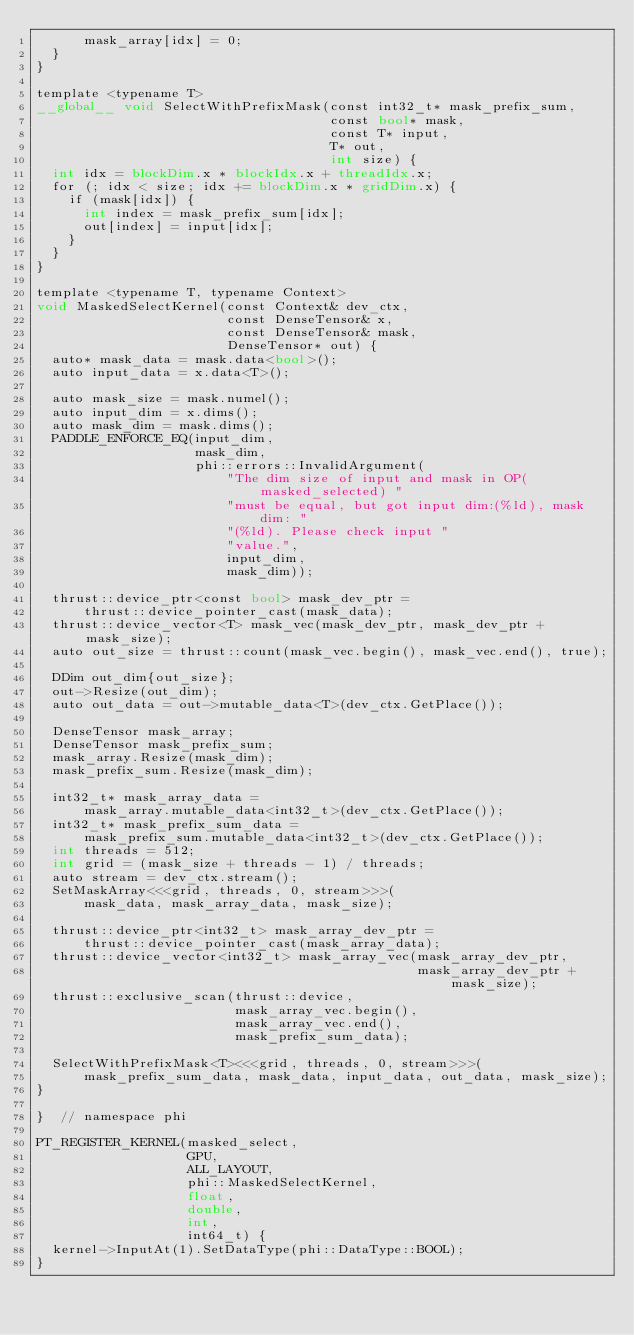Convert code to text. <code><loc_0><loc_0><loc_500><loc_500><_Cuda_>      mask_array[idx] = 0;
  }
}

template <typename T>
__global__ void SelectWithPrefixMask(const int32_t* mask_prefix_sum,
                                     const bool* mask,
                                     const T* input,
                                     T* out,
                                     int size) {
  int idx = blockDim.x * blockIdx.x + threadIdx.x;
  for (; idx < size; idx += blockDim.x * gridDim.x) {
    if (mask[idx]) {
      int index = mask_prefix_sum[idx];
      out[index] = input[idx];
    }
  }
}

template <typename T, typename Context>
void MaskedSelectKernel(const Context& dev_ctx,
                        const DenseTensor& x,
                        const DenseTensor& mask,
                        DenseTensor* out) {
  auto* mask_data = mask.data<bool>();
  auto input_data = x.data<T>();

  auto mask_size = mask.numel();
  auto input_dim = x.dims();
  auto mask_dim = mask.dims();
  PADDLE_ENFORCE_EQ(input_dim,
                    mask_dim,
                    phi::errors::InvalidArgument(
                        "The dim size of input and mask in OP(masked_selected) "
                        "must be equal, but got input dim:(%ld), mask dim: "
                        "(%ld). Please check input "
                        "value.",
                        input_dim,
                        mask_dim));

  thrust::device_ptr<const bool> mask_dev_ptr =
      thrust::device_pointer_cast(mask_data);
  thrust::device_vector<T> mask_vec(mask_dev_ptr, mask_dev_ptr + mask_size);
  auto out_size = thrust::count(mask_vec.begin(), mask_vec.end(), true);

  DDim out_dim{out_size};
  out->Resize(out_dim);
  auto out_data = out->mutable_data<T>(dev_ctx.GetPlace());

  DenseTensor mask_array;
  DenseTensor mask_prefix_sum;
  mask_array.Resize(mask_dim);
  mask_prefix_sum.Resize(mask_dim);

  int32_t* mask_array_data =
      mask_array.mutable_data<int32_t>(dev_ctx.GetPlace());
  int32_t* mask_prefix_sum_data =
      mask_prefix_sum.mutable_data<int32_t>(dev_ctx.GetPlace());
  int threads = 512;
  int grid = (mask_size + threads - 1) / threads;
  auto stream = dev_ctx.stream();
  SetMaskArray<<<grid, threads, 0, stream>>>(
      mask_data, mask_array_data, mask_size);

  thrust::device_ptr<int32_t> mask_array_dev_ptr =
      thrust::device_pointer_cast(mask_array_data);
  thrust::device_vector<int32_t> mask_array_vec(mask_array_dev_ptr,
                                                mask_array_dev_ptr + mask_size);
  thrust::exclusive_scan(thrust::device,
                         mask_array_vec.begin(),
                         mask_array_vec.end(),
                         mask_prefix_sum_data);

  SelectWithPrefixMask<T><<<grid, threads, 0, stream>>>(
      mask_prefix_sum_data, mask_data, input_data, out_data, mask_size);
}

}  // namespace phi

PT_REGISTER_KERNEL(masked_select,
                   GPU,
                   ALL_LAYOUT,
                   phi::MaskedSelectKernel,
                   float,
                   double,
                   int,
                   int64_t) {
  kernel->InputAt(1).SetDataType(phi::DataType::BOOL);
}
</code> 